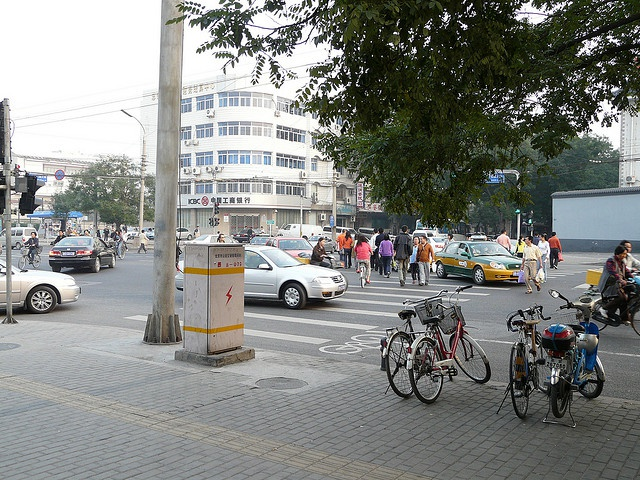Describe the objects in this image and their specific colors. I can see bicycle in white, black, gray, darkgray, and maroon tones, car in white, darkgray, black, and gray tones, motorcycle in white, black, gray, navy, and darkgray tones, bicycle in white, black, gray, darkgray, and maroon tones, and car in white, lightgray, black, darkgray, and olive tones in this image. 